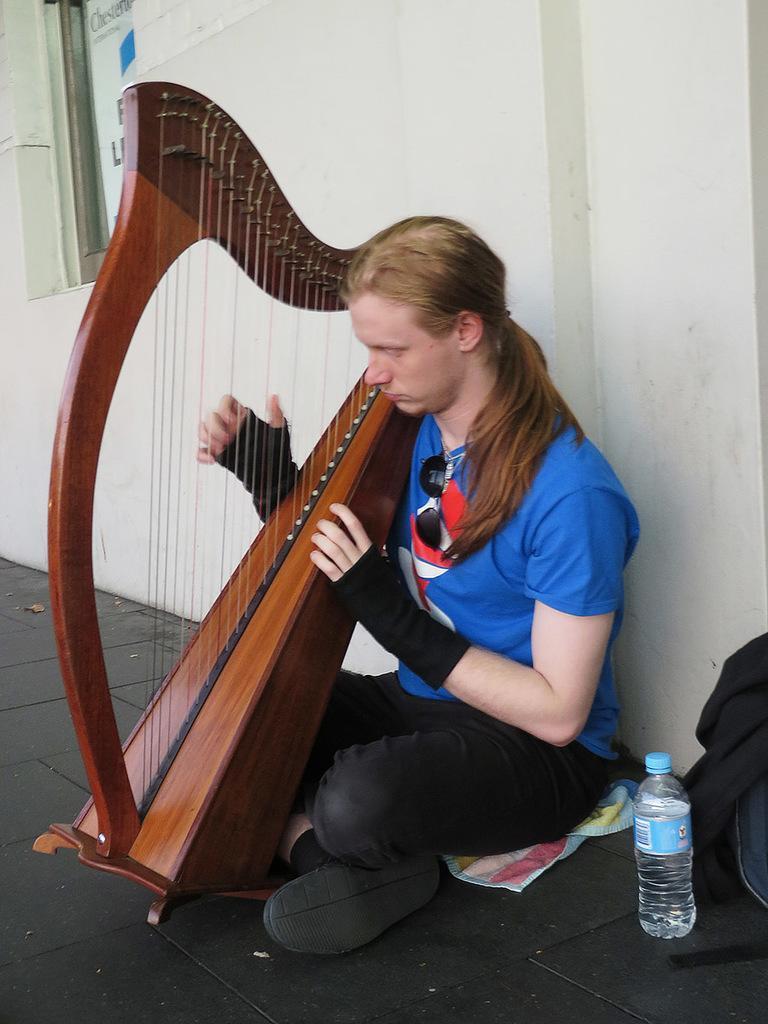Please provide a concise description of this image. This picture is taken outside a building. In the middle a person is sitting wearing a blue t-shirt and a black pant. He is having long hair. He is playing one musical instrument. Beside him there is a water bottle. in the background there is a white wall. On the left top corner there is a window. 